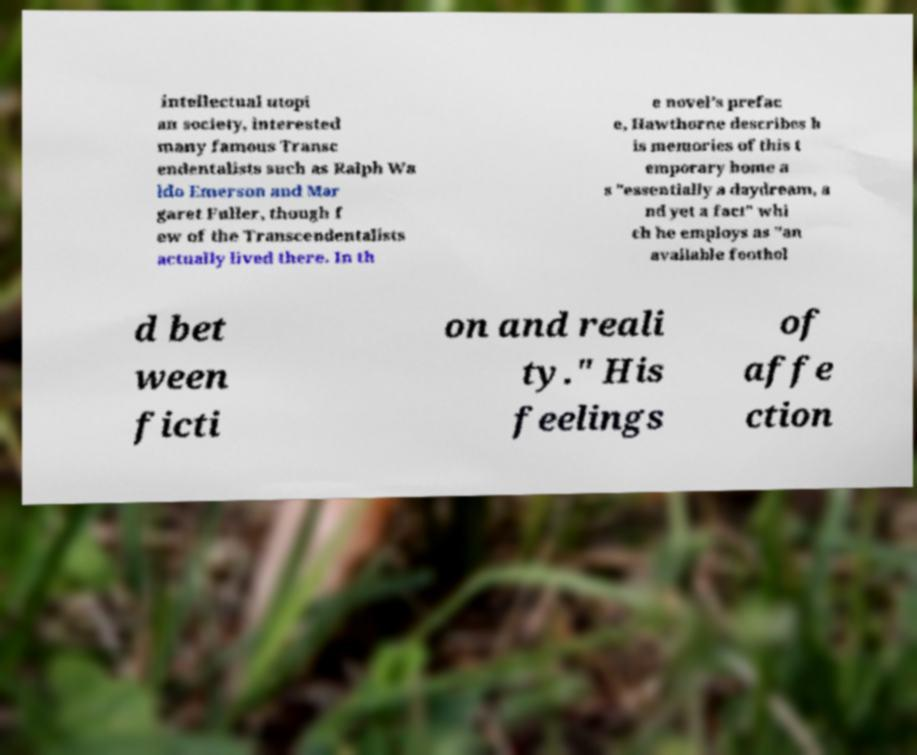Please identify and transcribe the text found in this image. intellectual utopi an society, interested many famous Transc endentalists such as Ralph Wa ldo Emerson and Mar garet Fuller, though f ew of the Transcendentalists actually lived there. In th e novel's prefac e, Hawthorne describes h is memories of this t emporary home a s "essentially a daydream, a nd yet a fact" whi ch he employs as "an available foothol d bet ween ficti on and reali ty." His feelings of affe ction 